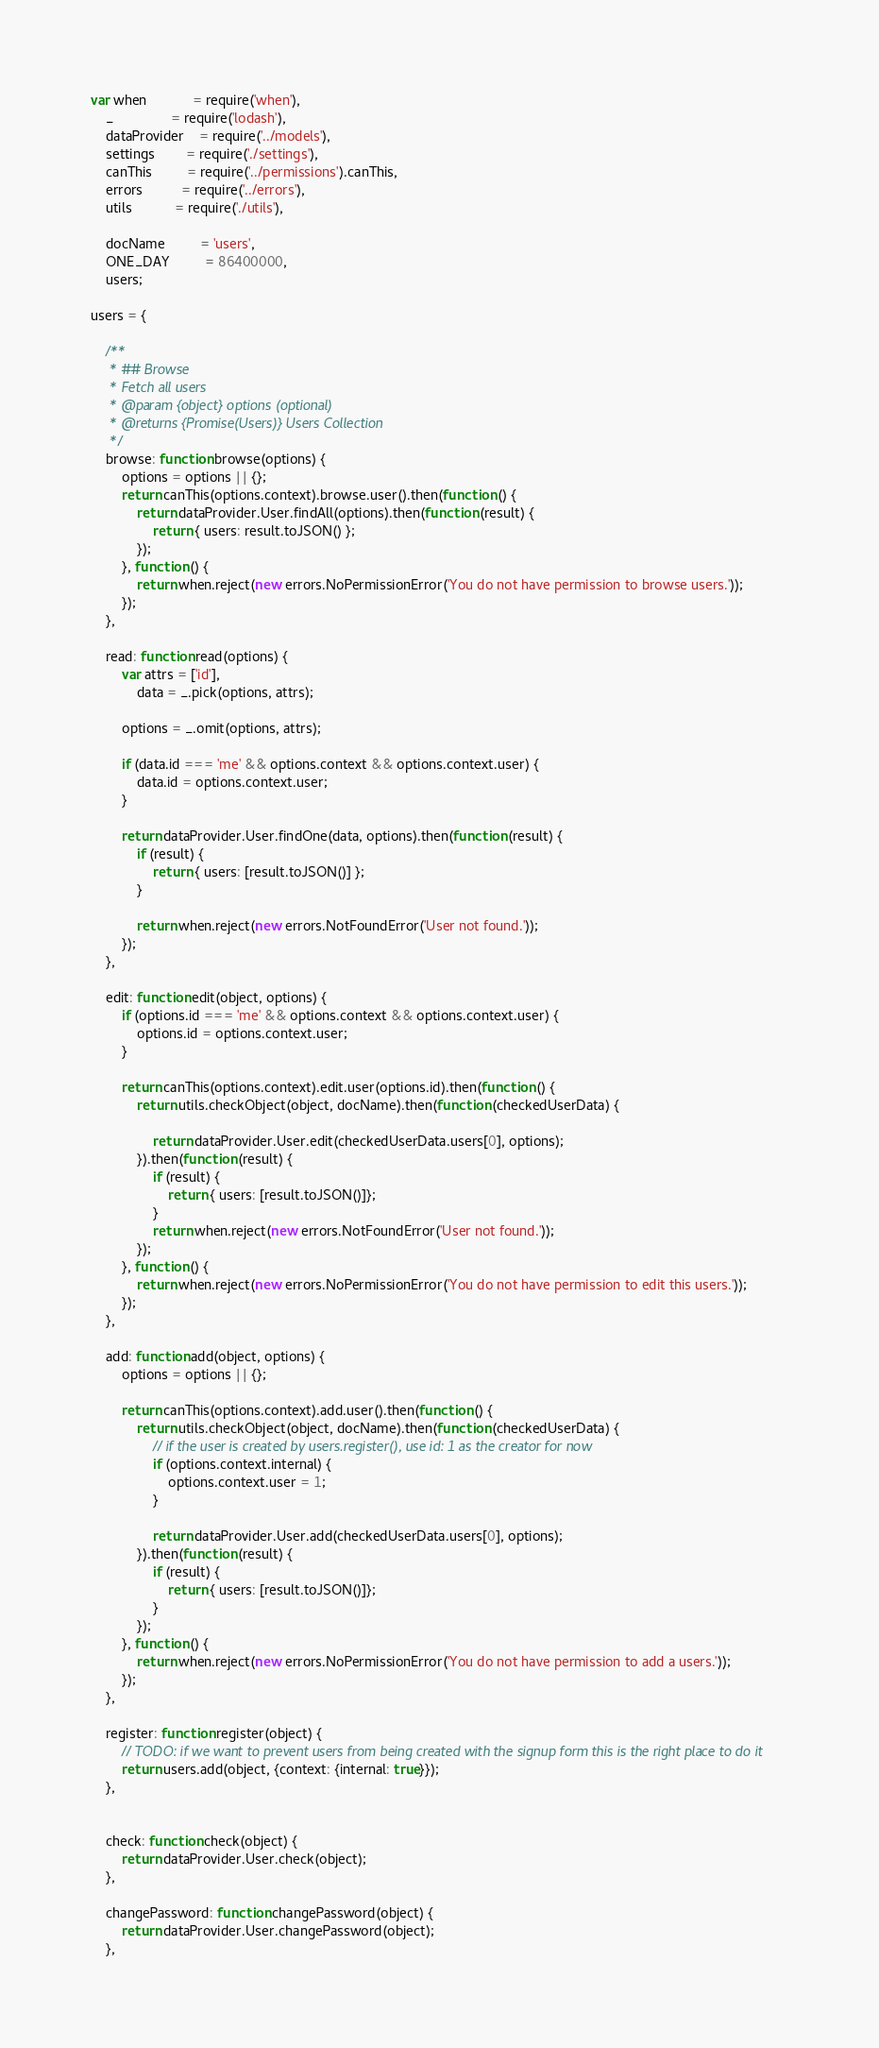Convert code to text. <code><loc_0><loc_0><loc_500><loc_500><_JavaScript_>var when            = require('when'),
    _               = require('lodash'),
    dataProvider    = require('../models'),
    settings        = require('./settings'),
    canThis         = require('../permissions').canThis,
    errors          = require('../errors'),
    utils           = require('./utils'),

    docName         = 'users',
    ONE_DAY         = 86400000,
    users;

users = {

    /**
     * ## Browse
     * Fetch all users
     * @param {object} options (optional)
     * @returns {Promise(Users)} Users Collection
     */
    browse: function browse(options) {
        options = options || {};
        return canThis(options.context).browse.user().then(function () {
            return dataProvider.User.findAll(options).then(function (result) {
                return { users: result.toJSON() };
            });
        }, function () {
            return when.reject(new errors.NoPermissionError('You do not have permission to browse users.'));
        });
    },

    read: function read(options) {
        var attrs = ['id'],
            data = _.pick(options, attrs);

        options = _.omit(options, attrs);

        if (data.id === 'me' && options.context && options.context.user) {
            data.id = options.context.user;
        }

        return dataProvider.User.findOne(data, options).then(function (result) {
            if (result) {
                return { users: [result.toJSON()] };
            }

            return when.reject(new errors.NotFoundError('User not found.'));
        });
    },

    edit: function edit(object, options) {
        if (options.id === 'me' && options.context && options.context.user) {
            options.id = options.context.user;
        }

        return canThis(options.context).edit.user(options.id).then(function () {
            return utils.checkObject(object, docName).then(function (checkedUserData) {

                return dataProvider.User.edit(checkedUserData.users[0], options);
            }).then(function (result) {
                if (result) {
                    return { users: [result.toJSON()]};
                }
                return when.reject(new errors.NotFoundError('User not found.'));
            });
        }, function () {
            return when.reject(new errors.NoPermissionError('You do not have permission to edit this users.'));
        });
    },

    add: function add(object, options) {
        options = options || {};

        return canThis(options.context).add.user().then(function () {
            return utils.checkObject(object, docName).then(function (checkedUserData) {
                // if the user is created by users.register(), use id: 1 as the creator for now
                if (options.context.internal) {
                    options.context.user = 1;
                }

                return dataProvider.User.add(checkedUserData.users[0], options);
            }).then(function (result) {
                if (result) {
                    return { users: [result.toJSON()]};
                }
            });
        }, function () {
            return when.reject(new errors.NoPermissionError('You do not have permission to add a users.'));
        });
    },

    register: function register(object) {
        // TODO: if we want to prevent users from being created with the signup form this is the right place to do it
        return users.add(object, {context: {internal: true}});
    },


    check: function check(object) {
        return dataProvider.User.check(object);
    },

    changePassword: function changePassword(object) {
        return dataProvider.User.changePassword(object);
    },
</code> 